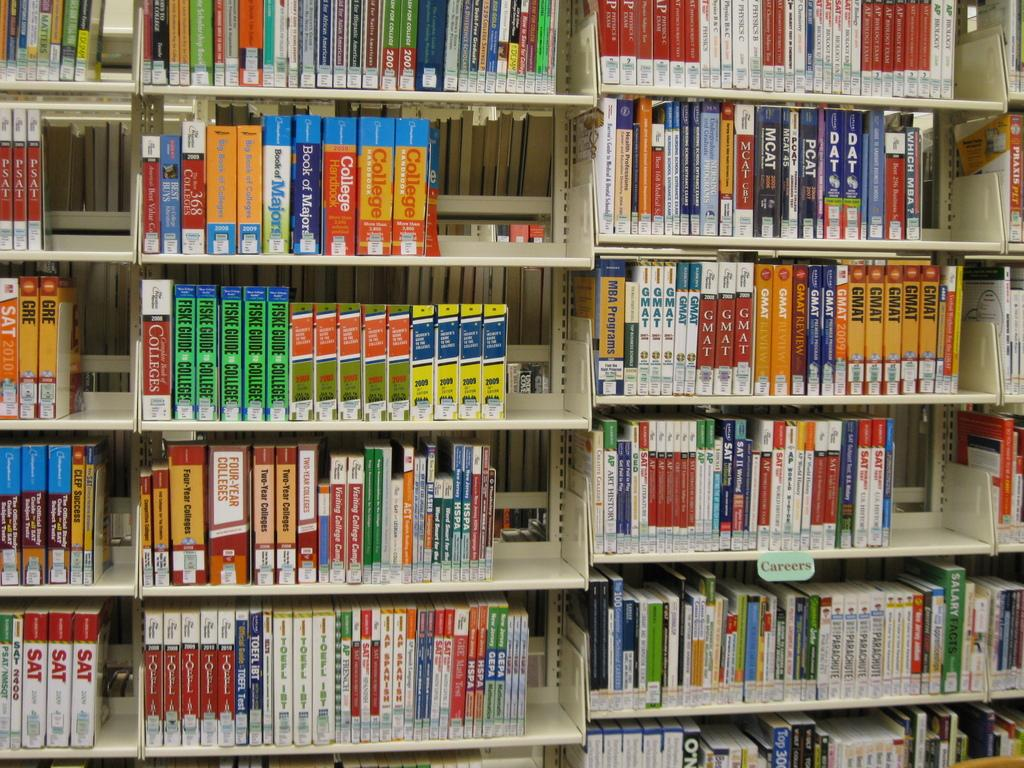What objects are visible in the image? There are many books in the image. Where are the books located? The books are kept in a bookshelf. What type of gun can be seen in the image? There is no gun present in the image; it features many books in a bookshelf. What type of teeth can be seen in the image? There are no teeth visible in the image, as it features books in a bookshelf. 